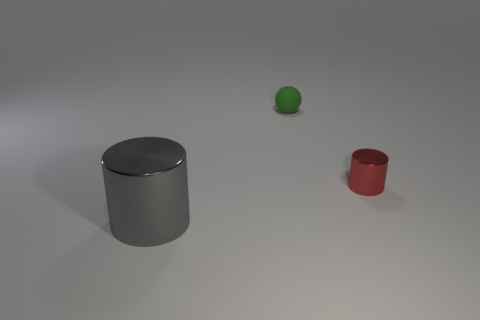Add 1 tiny rubber things. How many objects exist? 4 Subtract all cylinders. How many objects are left? 1 Add 1 tiny gray matte spheres. How many tiny gray matte spheres exist? 1 Subtract 0 brown balls. How many objects are left? 3 Subtract all tiny cyan rubber spheres. Subtract all matte spheres. How many objects are left? 2 Add 3 cylinders. How many cylinders are left? 5 